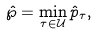<formula> <loc_0><loc_0><loc_500><loc_500>\hat { \wp } = \min _ { \tau \in \mathcal { U } } \hat { p } _ { \tau } ,</formula> 